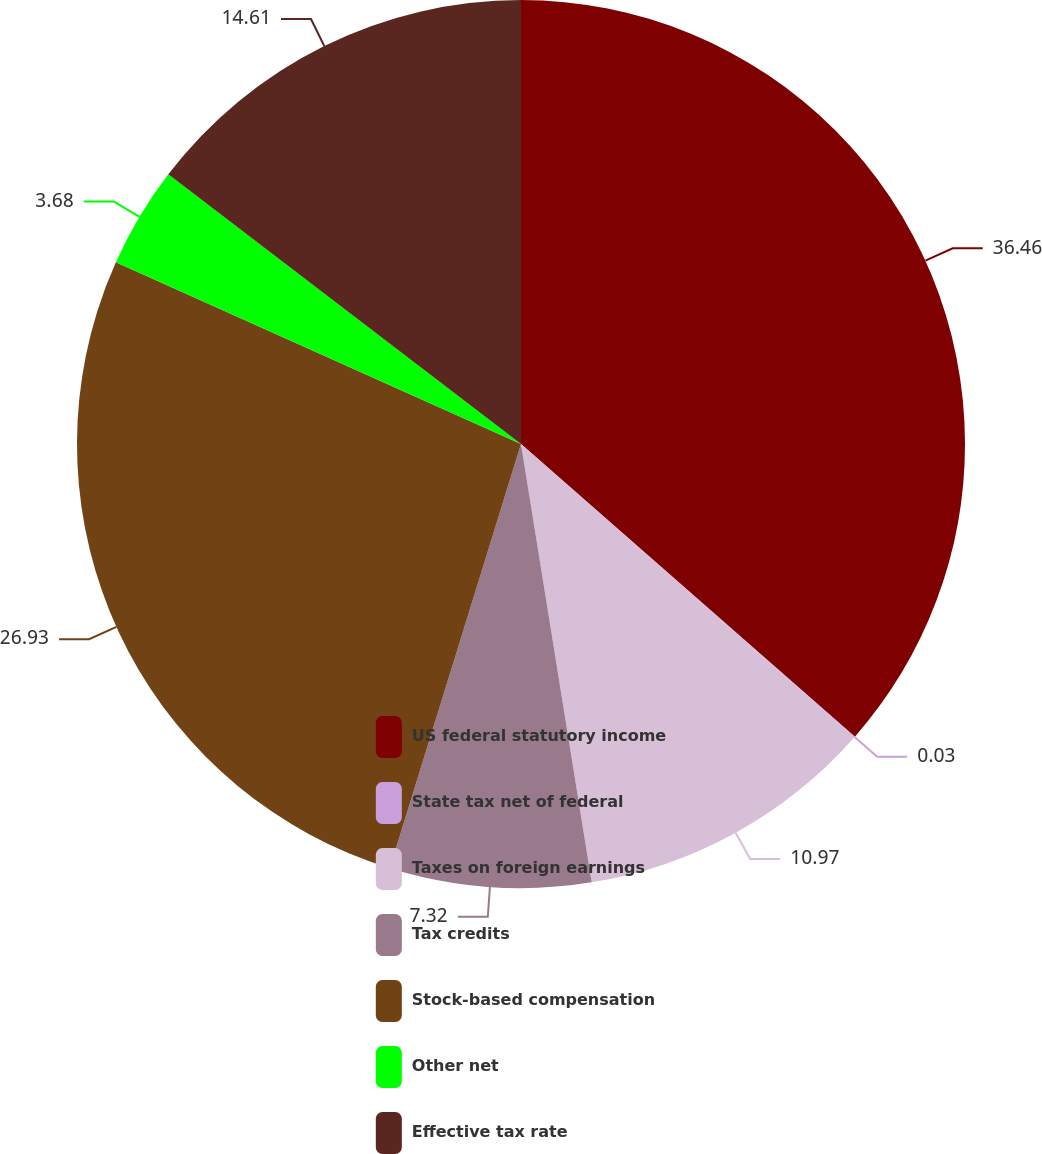<chart> <loc_0><loc_0><loc_500><loc_500><pie_chart><fcel>US federal statutory income<fcel>State tax net of federal<fcel>Taxes on foreign earnings<fcel>Tax credits<fcel>Stock-based compensation<fcel>Other net<fcel>Effective tax rate<nl><fcel>36.45%<fcel>0.03%<fcel>10.97%<fcel>7.32%<fcel>26.93%<fcel>3.68%<fcel>14.61%<nl></chart> 